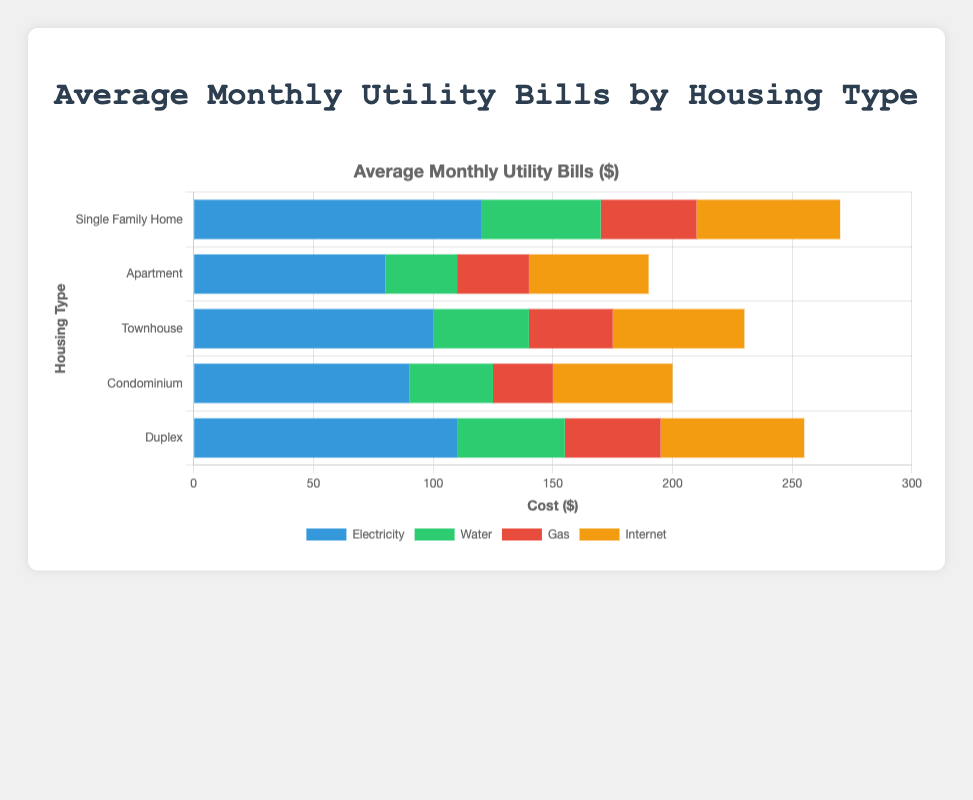Which housing type has the highest average monthly electricity bill? By looking at the horizontal grouped bar chart, we can see that "Single Family Home" has the longest bar in the Electricity category, which represents the highest average monthly electricity bill of $120.
Answer: Single Family Home Which housing type has the lowest average monthly gas bill? By inspecting the Gas bars, we see that "Condominium" has the shortest bar in this category, indicating the lowest average monthly gas bill of $25.
Answer: Condominium What is the combined average monthly bill for water and internet for a Townhouse? The Water bill for a Townhouse is $40 and the Internet bill is $55. Adding them together gives us 40 + 55 = $95.
Answer: $95 How much more do Single Family Homes spend on electricity compared to Apartments? The Electricity bill for a Single Family Home is $120 and for an Apartment it is $80. The difference is 120 - 80 = $40.
Answer: $40 Which housing type has the highest total average monthly utility bill? To find this, we sum all utility bills per housing type. Summing the bills:
- Single Family Home: 120 + 50 + 40 + 60 = $270
- Apartment: 80 + 30 + 30 + 50 = $190
- Townhouse: 100 + 40 + 35 + 55 = $230
- Condominium: 90 + 35 + 25 + 50 = $200
- Duplex: 110 + 45 + 40 + 60 = $255
Single Family Home has the highest total at $270.
Answer: Single Family Home Which utility has the smallest variation across all housing types? Visually inspecting the length of bars, the Gas category seems the most consistent in length across all housing types, indicating the smallest variation.
Answer: Gas What is the average monthly internet bill across all housing types? The values for the Internet bills are: 60, 50, 55, 50, 60. Averaging these:
(60 + 50 + 55 + 50 + 60) / 5 = 275 / 5 = $55.
Answer: $55 What is the visual color associated with the Internet bill in the chart? Examining the bars and the legend, the Internet bill is represented by the color orange.
Answer: Orange How much more does a Duplex spend on utilities compared to a Condominium? Summing the bills for both:
- Duplex: 110 + 45 + 40 + 60 = $255
- Condominium: 90 + 35 + 25 + 50 = $200
The difference is 255 - 200 = $55 more.
Answer: $55 What is the difference between the highest and lowest average monthly water bills? The highest average monthly water bill is for Single Family Home at $50, and the lowest is for Apartment at $30. The difference is 50 - 30 = $20.
Answer: $20 